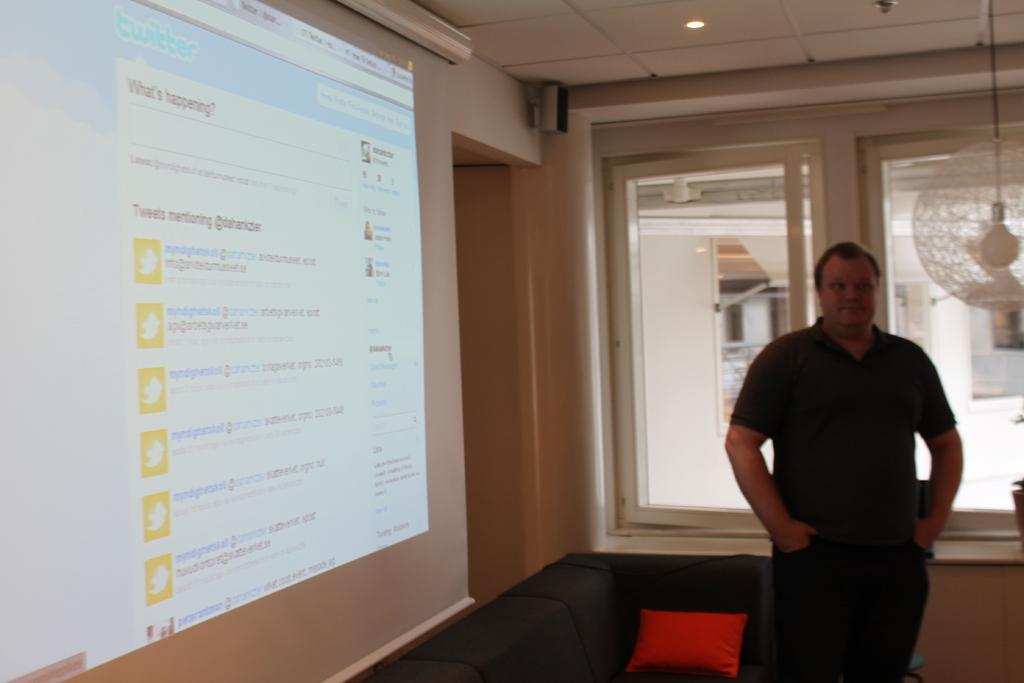Can you describe this image briefly? In this picture we can see a person is standing and on the left side of the man there is a red cushion on the couch. On the left side of the couch where is the projector screen. At the top there is the ceiling light. Behind the man there is a glass window and an object. Behind the window, there are some blurred objects. 